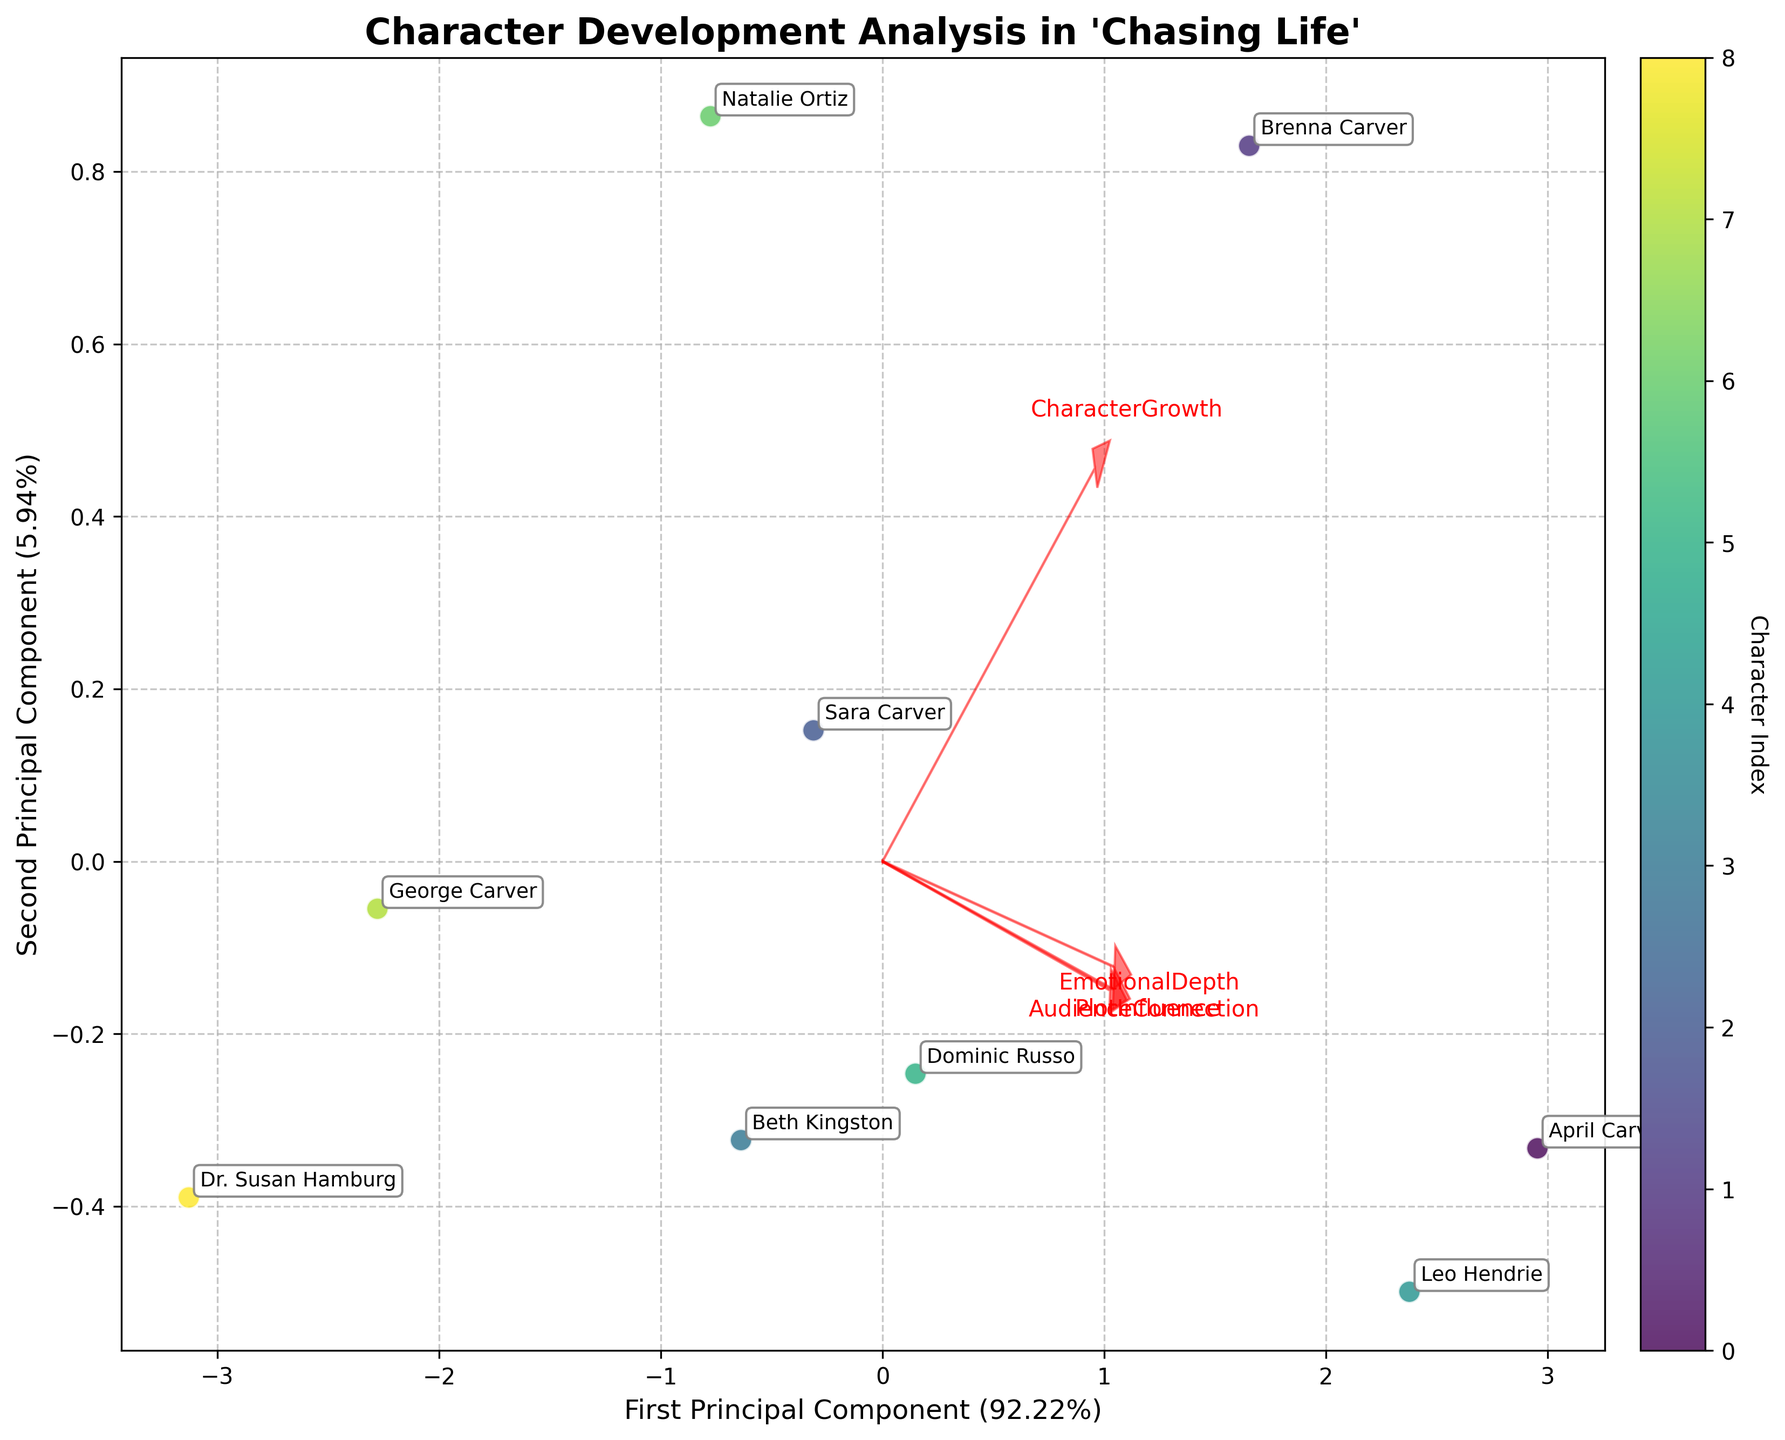What is the main title of the figure? The main title of the figure describes the general theme or subject matter. From the provided code, it's clear that the main title is "Character Development Analysis in 'Chasing Life'".
Answer: Character Development Analysis in 'Chasing Life' How many characters are analyzed in the figure? Each character is represented as a data point on the biplot. Counting the number of data points or annotations directly tells us the number of characters analyzed.
Answer: 9 Which character has the highest Audience Connection? Audience Connection is plotted and represented by the location of data points. By checking the annotations and locations, we find that Leo Hendrie has the highest Audience Connection value of 9.1.
Answer: Leo Hendrie Which two features appear to be the most influential in the first principal component? The first principal component is influenced by the features with the largest projection along the x-axis. By examining the arrows and their lengths, we determine the most influential features.
Answer: EmotionalDepth and PlotInfluence Which character shows the greatest overall character growth according to the biplot? By checking character annotations and positions, Brenna Carver stands out with the highest Character Growth value of 9.1, indicated by her position on the plot and confirmed by the data.
Answer: Brenna Carver Are there any two characters with similar positioning on the biplot? By observing the clusters and distances between data points, find two close characters. Sara Carver and Dominic Russo are closely positioned, indicating they share similar character development traits.
Answer: Sara Carver and Dominic Russo Which character is positioned closest to the origin of the biplot? The character closest to the origin (0, 0) of the biplot can be seen by examining the data points. George Carver is closest to the origin, indicating average values across the traits.
Answer: George Carver What percentage of the variance is explained by the first two principal components combined? The explained variance percentages are typically indicated on the axes labels. By summing up the percentages shown on the x-axis and y-axis, we get the total explained variance.
Answer: 100% How do April Carver and Leo Hendrie compare in Emotional Depth? Comparing their positions and considering the direction and length of the EmotionalDepth arrow shows that both have high Emotional Depth, with April Carver scoring slightly higher.
Answer: April Carver has slightly higher Emotional Depth than Leo Hendrie 